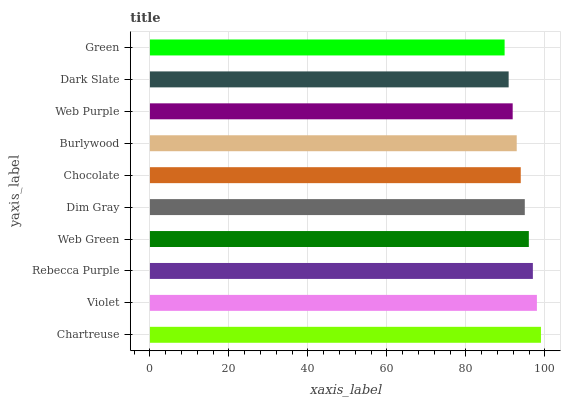Is Green the minimum?
Answer yes or no. Yes. Is Chartreuse the maximum?
Answer yes or no. Yes. Is Violet the minimum?
Answer yes or no. No. Is Violet the maximum?
Answer yes or no. No. Is Chartreuse greater than Violet?
Answer yes or no. Yes. Is Violet less than Chartreuse?
Answer yes or no. Yes. Is Violet greater than Chartreuse?
Answer yes or no. No. Is Chartreuse less than Violet?
Answer yes or no. No. Is Dim Gray the high median?
Answer yes or no. Yes. Is Chocolate the low median?
Answer yes or no. Yes. Is Rebecca Purple the high median?
Answer yes or no. No. Is Web Green the low median?
Answer yes or no. No. 